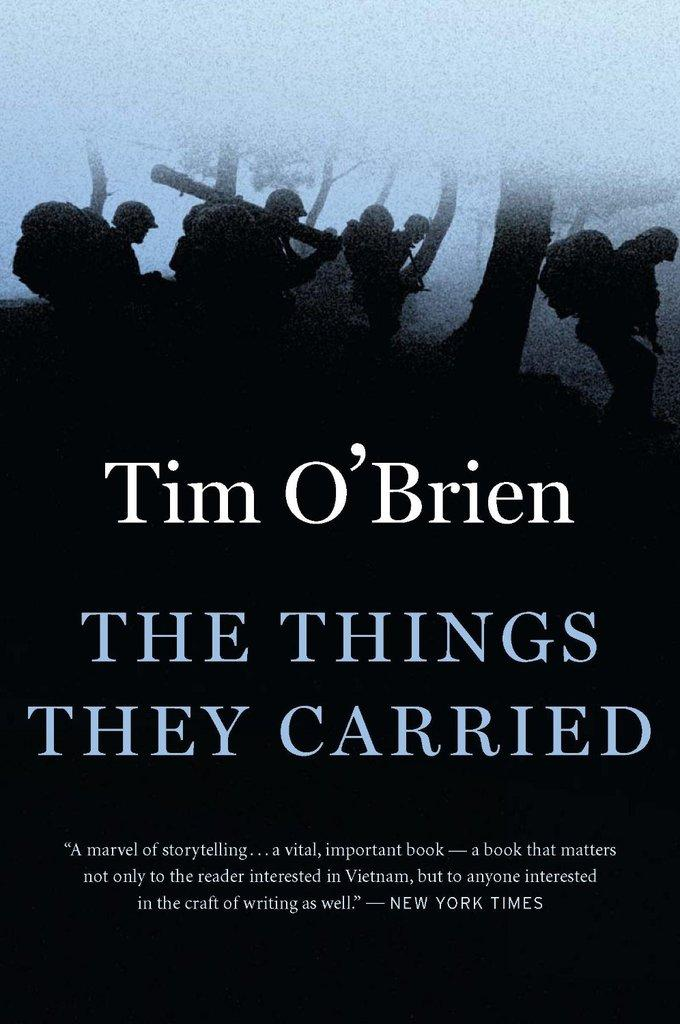<image>
Create a compact narrative representing the image presented. a cover of Tim O'Brien's book The Things They Carried 